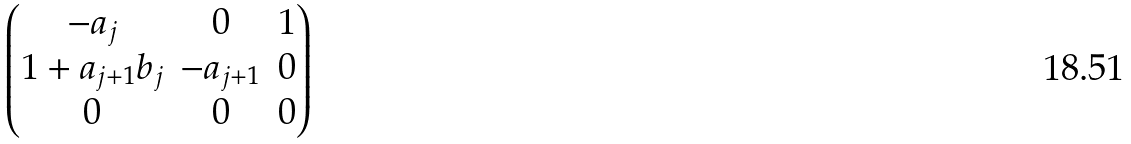<formula> <loc_0><loc_0><loc_500><loc_500>\begin{pmatrix} - a _ { j } & 0 & 1 \\ 1 + a _ { j + 1 } b _ { j } & - a _ { j + 1 } & 0 \\ 0 & 0 & 0 \end{pmatrix}</formula> 